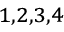Convert formula to latex. <formula><loc_0><loc_0><loc_500><loc_500>^ { 1 , 2 , 3 , 4 }</formula> 